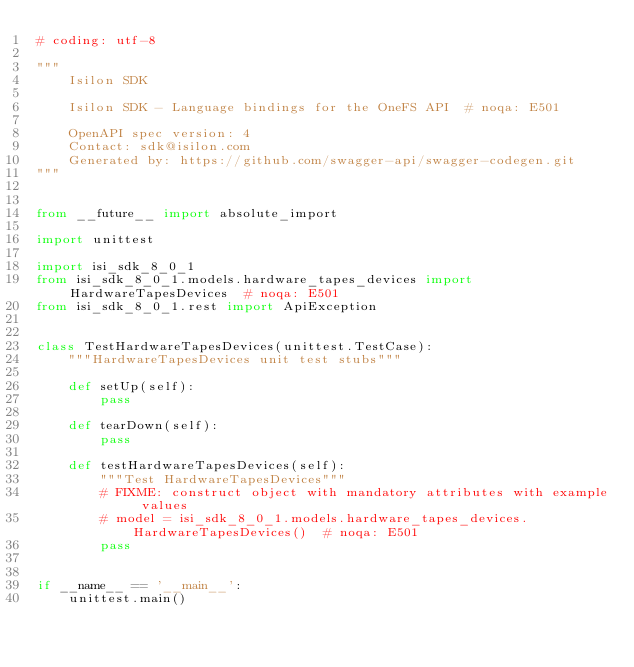<code> <loc_0><loc_0><loc_500><loc_500><_Python_># coding: utf-8

"""
    Isilon SDK

    Isilon SDK - Language bindings for the OneFS API  # noqa: E501

    OpenAPI spec version: 4
    Contact: sdk@isilon.com
    Generated by: https://github.com/swagger-api/swagger-codegen.git
"""


from __future__ import absolute_import

import unittest

import isi_sdk_8_0_1
from isi_sdk_8_0_1.models.hardware_tapes_devices import HardwareTapesDevices  # noqa: E501
from isi_sdk_8_0_1.rest import ApiException


class TestHardwareTapesDevices(unittest.TestCase):
    """HardwareTapesDevices unit test stubs"""

    def setUp(self):
        pass

    def tearDown(self):
        pass

    def testHardwareTapesDevices(self):
        """Test HardwareTapesDevices"""
        # FIXME: construct object with mandatory attributes with example values
        # model = isi_sdk_8_0_1.models.hardware_tapes_devices.HardwareTapesDevices()  # noqa: E501
        pass


if __name__ == '__main__':
    unittest.main()
</code> 